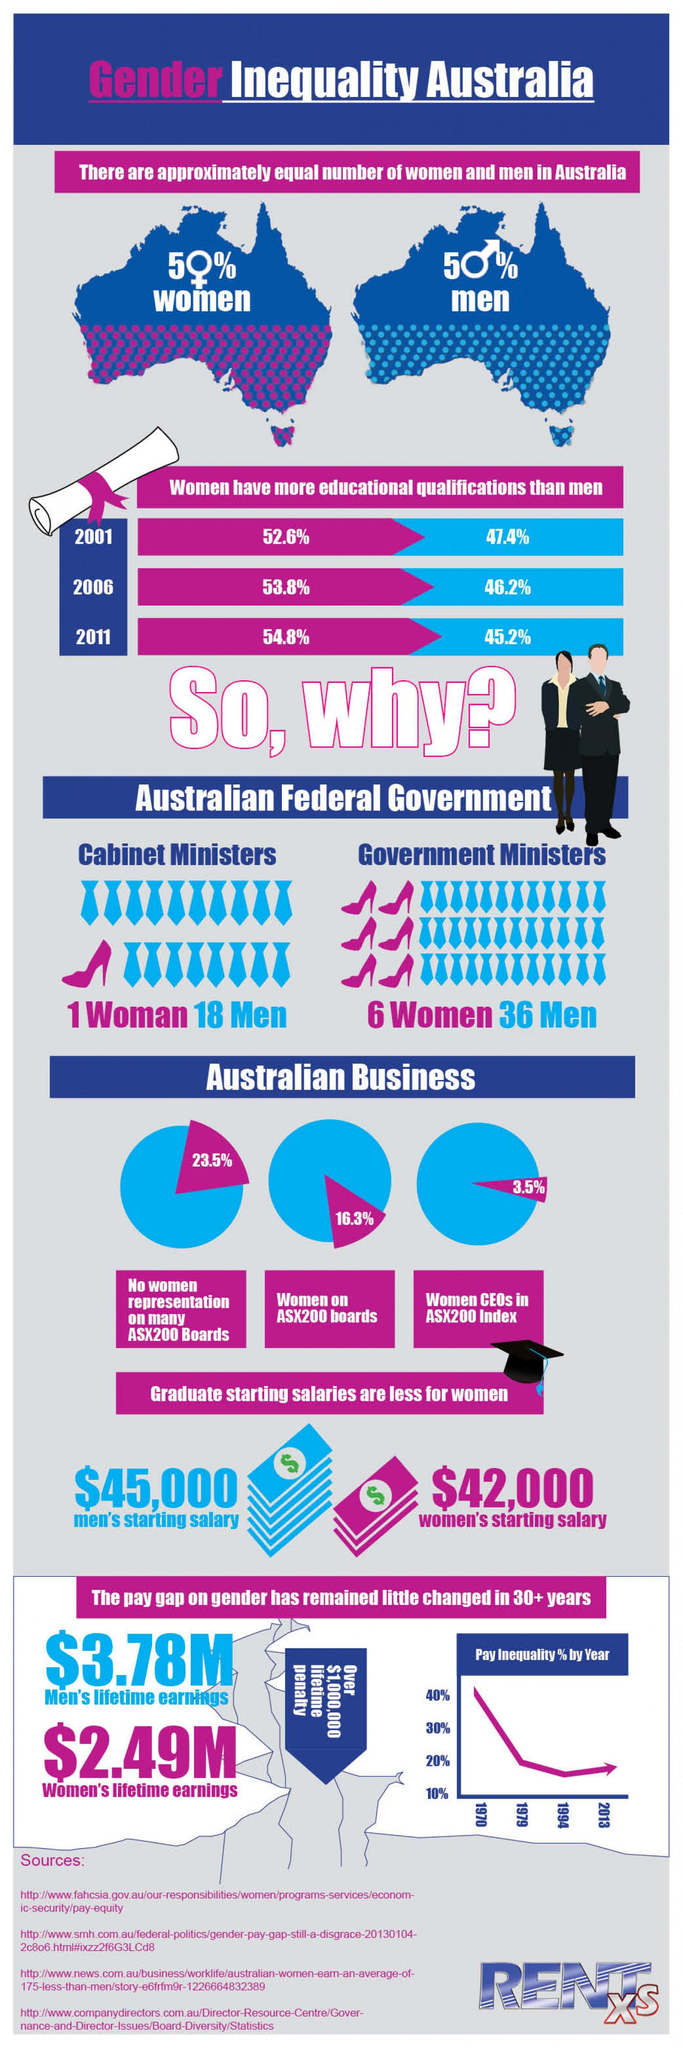Outline some significant characteristics in this image. The starting salary for women is $42,000. The starting salary for men is $45,000. 